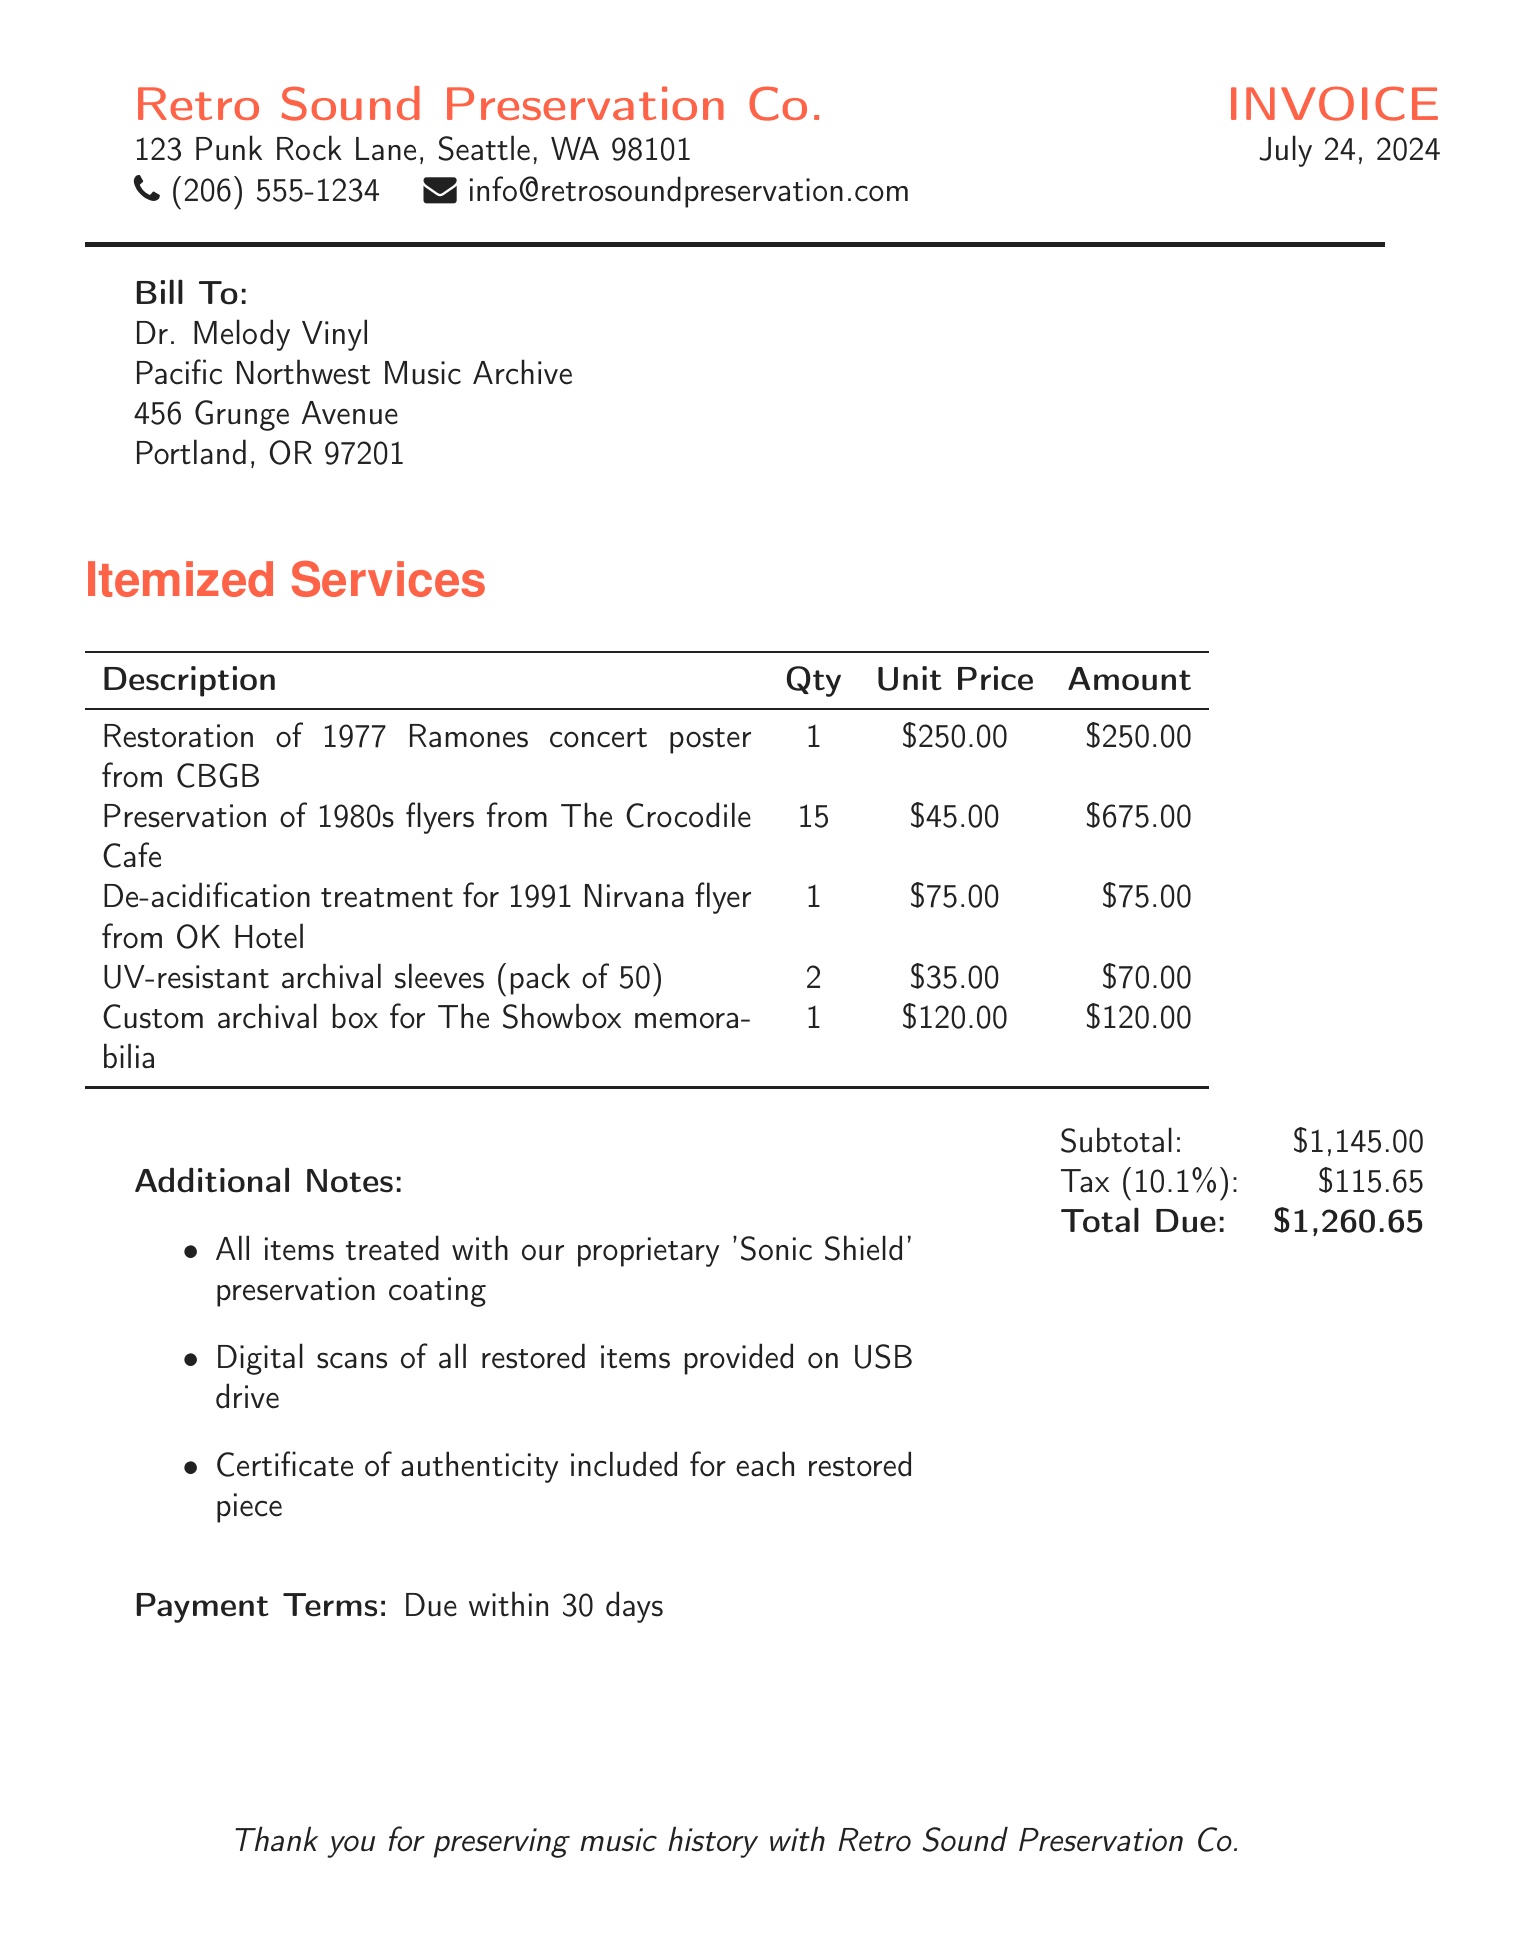What is the name of the company issuing the invoice? The name of the company is listed at the top of the invoice, which is Retro Sound Preservation Co.
Answer: Retro Sound Preservation Co Who is the recipient of the invoice? The recipient of the invoice, as indicated in the "Bill To" section, is Dr. Melody Vinyl.
Answer: Dr. Melody Vinyl What is the total amount due on the invoice? The total amount due is calculated at the end of the invoice, shown as Total Due.
Answer: $1,260.65 How many flyers from The Crocodile Cafe were preserved? The quantity of flyers preserved is mentioned in the itemized services section for the corresponding service.
Answer: 15 What date is the invoice dated? The date of the invoice is given at the top right corner, stating today’s date.
Answer: Today’s date What is included with each restored piece? The document specifies that a certificate of authenticity is included with each restored piece.
Answer: Certificate of authenticity What is the tax rate applied to the invoice? The tax rate is specified right before the tax amount, which is 10.1 percent.
Answer: 10.1% Which treatment was applied to the 1991 Nirvana flyer? The treatment applied is specified in the itemized services section for the corresponding item.
Answer: De-acidification treatment How many custom archival boxes were created? The quantity of the custom archival boxes is mentioned in the itemized services section for that service.
Answer: 1 